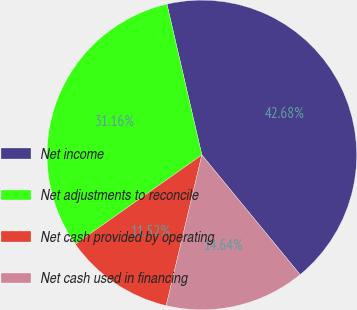Convert chart to OTSL. <chart><loc_0><loc_0><loc_500><loc_500><pie_chart><fcel>Net income<fcel>Net adjustments to reconcile<fcel>Net cash provided by operating<fcel>Net cash used in financing<nl><fcel>42.68%<fcel>31.16%<fcel>11.52%<fcel>14.64%<nl></chart> 